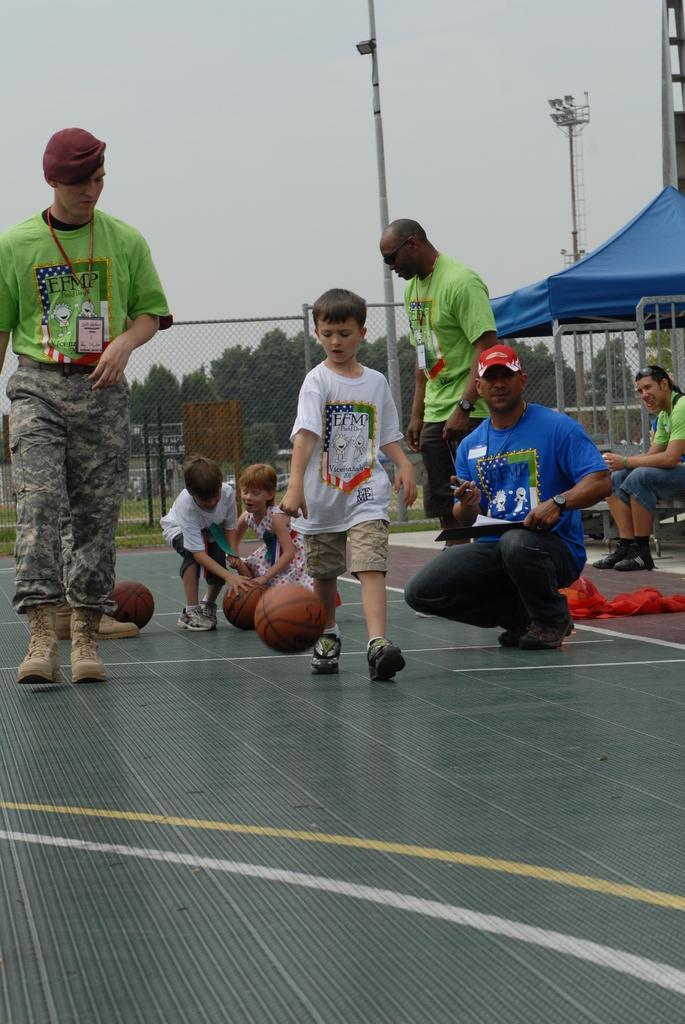Could you give a brief overview of what you see in this image? In this image, we can see people and some are wearing id cards and one of them is holding a paper and a pen. In the background, there are trees, poles, a mesh, tents and we can see a gate. At the bottom, there are balls and we can see a cloth on the floor. At the top, there is sky. 